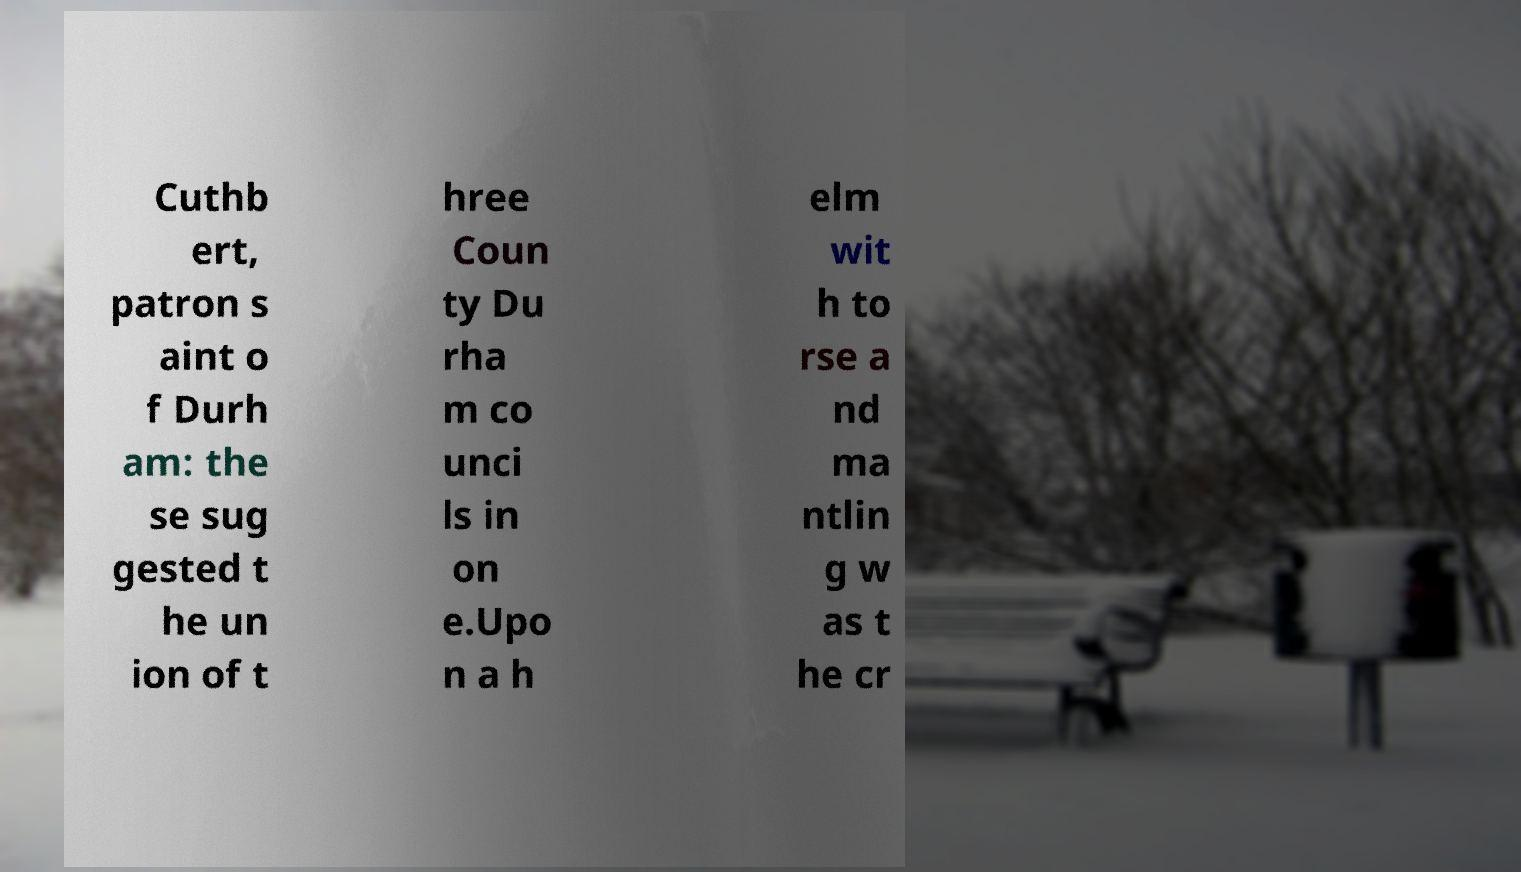Can you read and provide the text displayed in the image?This photo seems to have some interesting text. Can you extract and type it out for me? Cuthb ert, patron s aint o f Durh am: the se sug gested t he un ion of t hree Coun ty Du rha m co unci ls in on e.Upo n a h elm wit h to rse a nd ma ntlin g w as t he cr 